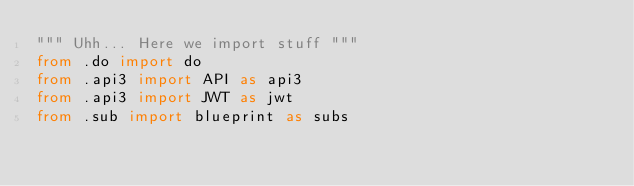<code> <loc_0><loc_0><loc_500><loc_500><_Python_>""" Uhh... Here we import stuff """
from .do import do
from .api3 import API as api3
from .api3 import JWT as jwt
from .sub import blueprint as subs
</code> 